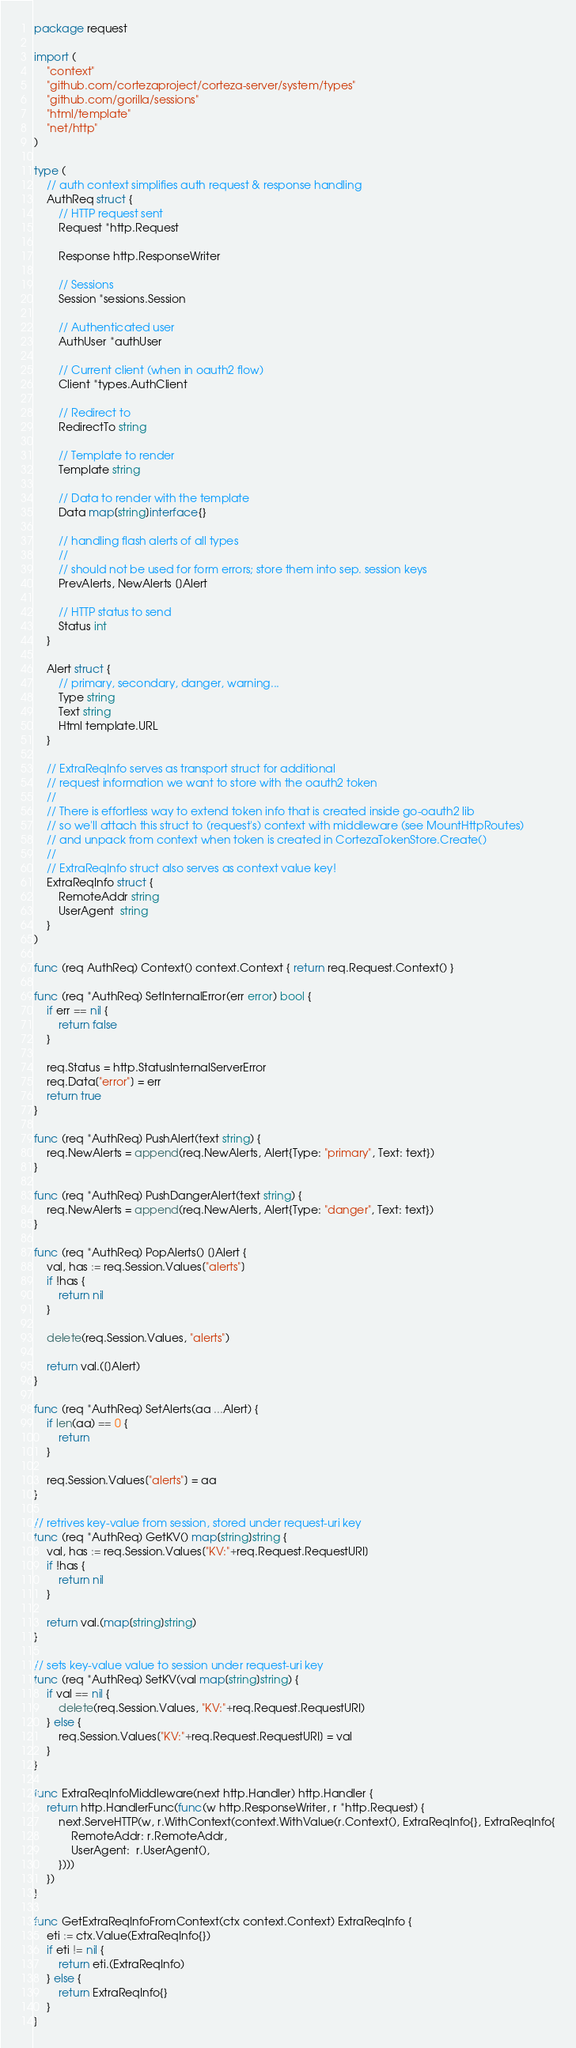Convert code to text. <code><loc_0><loc_0><loc_500><loc_500><_Go_>package request

import (
	"context"
	"github.com/cortezaproject/corteza-server/system/types"
	"github.com/gorilla/sessions"
	"html/template"
	"net/http"
)

type (
	// auth context simplifies auth request & response handling
	AuthReq struct {
		// HTTP request sent
		Request *http.Request

		Response http.ResponseWriter

		// Sessions
		Session *sessions.Session

		// Authenticated user
		AuthUser *authUser

		// Current client (when in oauth2 flow)
		Client *types.AuthClient

		// Redirect to
		RedirectTo string

		// Template to render
		Template string

		// Data to render with the template
		Data map[string]interface{}

		// handling flash alerts of all types
		//
		// should not be used for form errors; store them into sep. session keys
		PrevAlerts, NewAlerts []Alert

		// HTTP status to send
		Status int
	}

	Alert struct {
		// primary, secondary, danger, warning...
		Type string
		Text string
		Html template.URL
	}

	// ExtraReqInfo serves as transport struct for additional
	// request information we want to store with the oauth2 token
	//
	// There is effortless way to extend token info that is created inside go-oauth2 lib
	// so we'll attach this struct to (request's) context with middleware (see MountHttpRoutes)
	// and unpack from context when token is created in CortezaTokenStore.Create()
	//
	// ExtraReqInfo struct also serves as context value key!
	ExtraReqInfo struct {
		RemoteAddr string
		UserAgent  string
	}
)

func (req AuthReq) Context() context.Context { return req.Request.Context() }

func (req *AuthReq) SetInternalError(err error) bool {
	if err == nil {
		return false
	}

	req.Status = http.StatusInternalServerError
	req.Data["error"] = err
	return true
}

func (req *AuthReq) PushAlert(text string) {
	req.NewAlerts = append(req.NewAlerts, Alert{Type: "primary", Text: text})
}

func (req *AuthReq) PushDangerAlert(text string) {
	req.NewAlerts = append(req.NewAlerts, Alert{Type: "danger", Text: text})
}

func (req *AuthReq) PopAlerts() []Alert {
	val, has := req.Session.Values["alerts"]
	if !has {
		return nil
	}

	delete(req.Session.Values, "alerts")

	return val.([]Alert)
}

func (req *AuthReq) SetAlerts(aa ...Alert) {
	if len(aa) == 0 {
		return
	}

	req.Session.Values["alerts"] = aa
}

// retrives key-value from session, stored under request-uri key
func (req *AuthReq) GetKV() map[string]string {
	val, has := req.Session.Values["KV:"+req.Request.RequestURI]
	if !has {
		return nil
	}

	return val.(map[string]string)
}

// sets key-value value to session under request-uri key
func (req *AuthReq) SetKV(val map[string]string) {
	if val == nil {
		delete(req.Session.Values, "KV:"+req.Request.RequestURI)
	} else {
		req.Session.Values["KV:"+req.Request.RequestURI] = val
	}
}

func ExtraReqInfoMiddleware(next http.Handler) http.Handler {
	return http.HandlerFunc(func(w http.ResponseWriter, r *http.Request) {
		next.ServeHTTP(w, r.WithContext(context.WithValue(r.Context(), ExtraReqInfo{}, ExtraReqInfo{
			RemoteAddr: r.RemoteAddr,
			UserAgent:  r.UserAgent(),
		})))
	})
}

func GetExtraReqInfoFromContext(ctx context.Context) ExtraReqInfo {
	eti := ctx.Value(ExtraReqInfo{})
	if eti != nil {
		return eti.(ExtraReqInfo)
	} else {
		return ExtraReqInfo{}
	}
}
</code> 